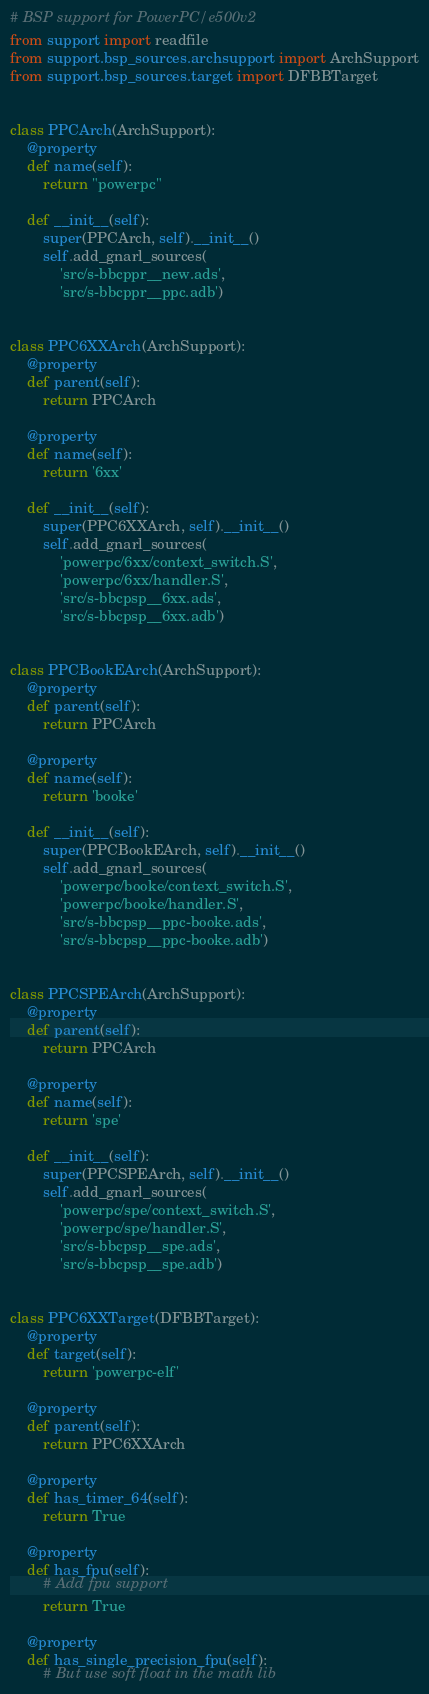Convert code to text. <code><loc_0><loc_0><loc_500><loc_500><_Python_># BSP support for PowerPC/e500v2
from support import readfile
from support.bsp_sources.archsupport import ArchSupport
from support.bsp_sources.target import DFBBTarget


class PPCArch(ArchSupport):
    @property
    def name(self):
        return "powerpc"

    def __init__(self):
        super(PPCArch, self).__init__()
        self.add_gnarl_sources(
            'src/s-bbcppr__new.ads',
            'src/s-bbcppr__ppc.adb')


class PPC6XXArch(ArchSupport):
    @property
    def parent(self):
        return PPCArch

    @property
    def name(self):
        return '6xx'

    def __init__(self):
        super(PPC6XXArch, self).__init__()
        self.add_gnarl_sources(
            'powerpc/6xx/context_switch.S',
            'powerpc/6xx/handler.S',
            'src/s-bbcpsp__6xx.ads',
            'src/s-bbcpsp__6xx.adb')


class PPCBookEArch(ArchSupport):
    @property
    def parent(self):
        return PPCArch

    @property
    def name(self):
        return 'booke'

    def __init__(self):
        super(PPCBookEArch, self).__init__()
        self.add_gnarl_sources(
            'powerpc/booke/context_switch.S',
            'powerpc/booke/handler.S',
            'src/s-bbcpsp__ppc-booke.ads',
            'src/s-bbcpsp__ppc-booke.adb')


class PPCSPEArch(ArchSupport):
    @property
    def parent(self):
        return PPCArch

    @property
    def name(self):
        return 'spe'

    def __init__(self):
        super(PPCSPEArch, self).__init__()
        self.add_gnarl_sources(
            'powerpc/spe/context_switch.S',
            'powerpc/spe/handler.S',
            'src/s-bbcpsp__spe.ads',
            'src/s-bbcpsp__spe.adb')


class PPC6XXTarget(DFBBTarget):
    @property
    def target(self):
        return 'powerpc-elf'

    @property
    def parent(self):
        return PPC6XXArch

    @property
    def has_timer_64(self):
        return True

    @property
    def has_fpu(self):
        # Add fpu support
        return True

    @property
    def has_single_precision_fpu(self):
        # But use soft float in the math lib</code> 